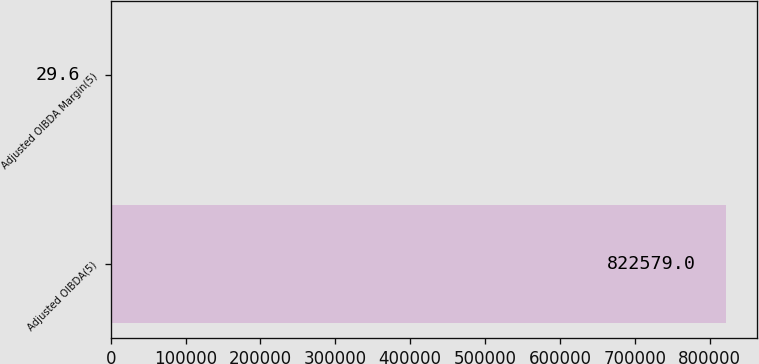<chart> <loc_0><loc_0><loc_500><loc_500><bar_chart><fcel>Adjusted OIBDA(5)<fcel>Adjusted OIBDA Margin(5)<nl><fcel>822579<fcel>29.6<nl></chart> 